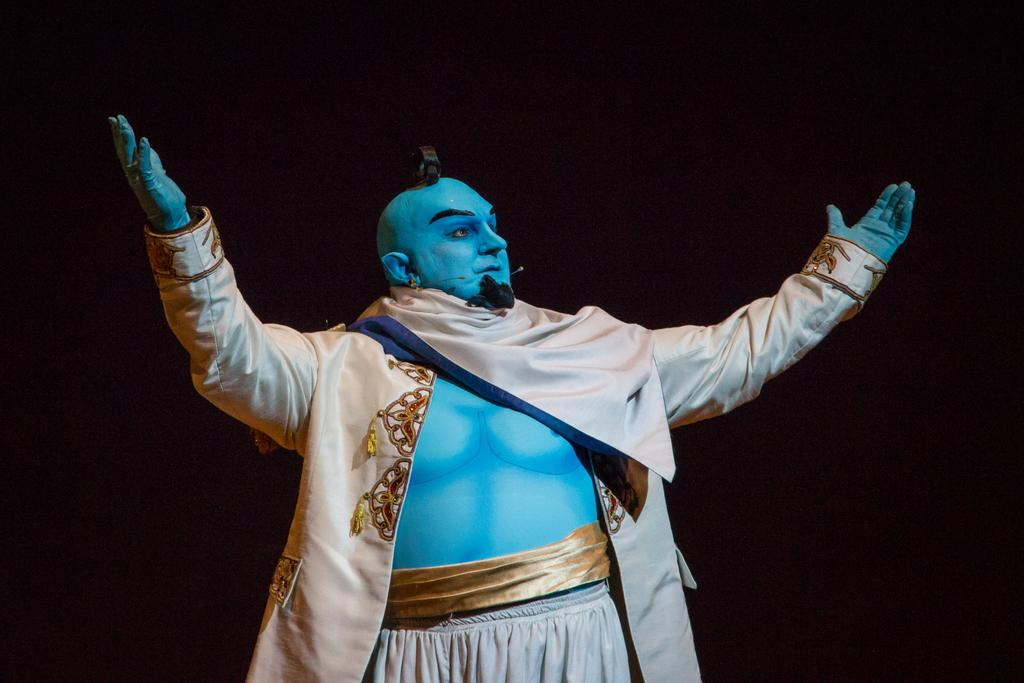Who is the main subject in the image? There is a man in the image. What is the man wearing? The man is wearing a shirt and trousers. What role does the man appear to be playing in the image? The man appears to be a genie. What object can be seen in the image that is typically used for amplifying sound? There is a microphone in the image. What is the color of the background in the image? The background of the image is dark. What type of dress is the man wearing in the image? The man is not wearing a dress; he is wearing a shirt and trousers. What shape is the square that the man is standing on in the image? There is no square present in the image; the man is standing on a dark background. 